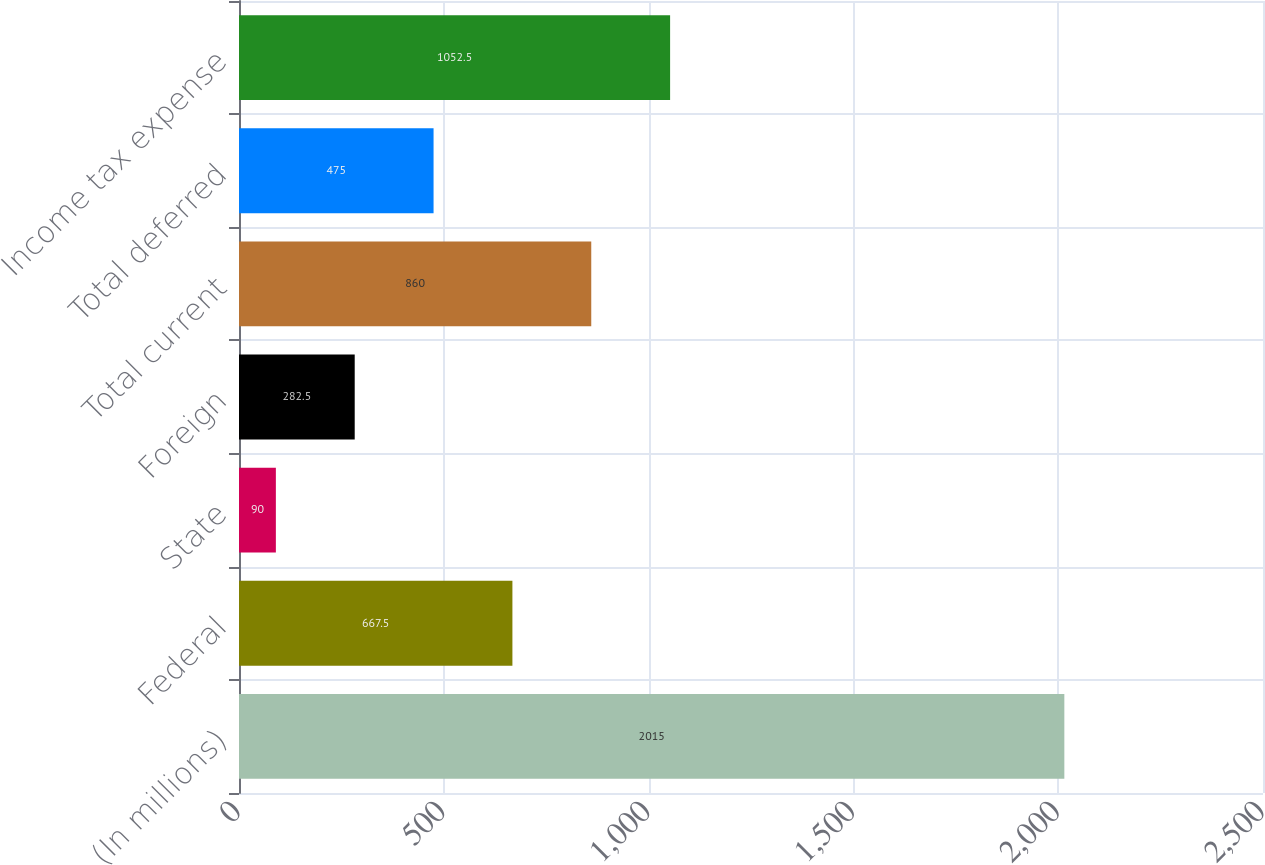Convert chart to OTSL. <chart><loc_0><loc_0><loc_500><loc_500><bar_chart><fcel>(In millions)<fcel>Federal<fcel>State<fcel>Foreign<fcel>Total current<fcel>Total deferred<fcel>Income tax expense<nl><fcel>2015<fcel>667.5<fcel>90<fcel>282.5<fcel>860<fcel>475<fcel>1052.5<nl></chart> 